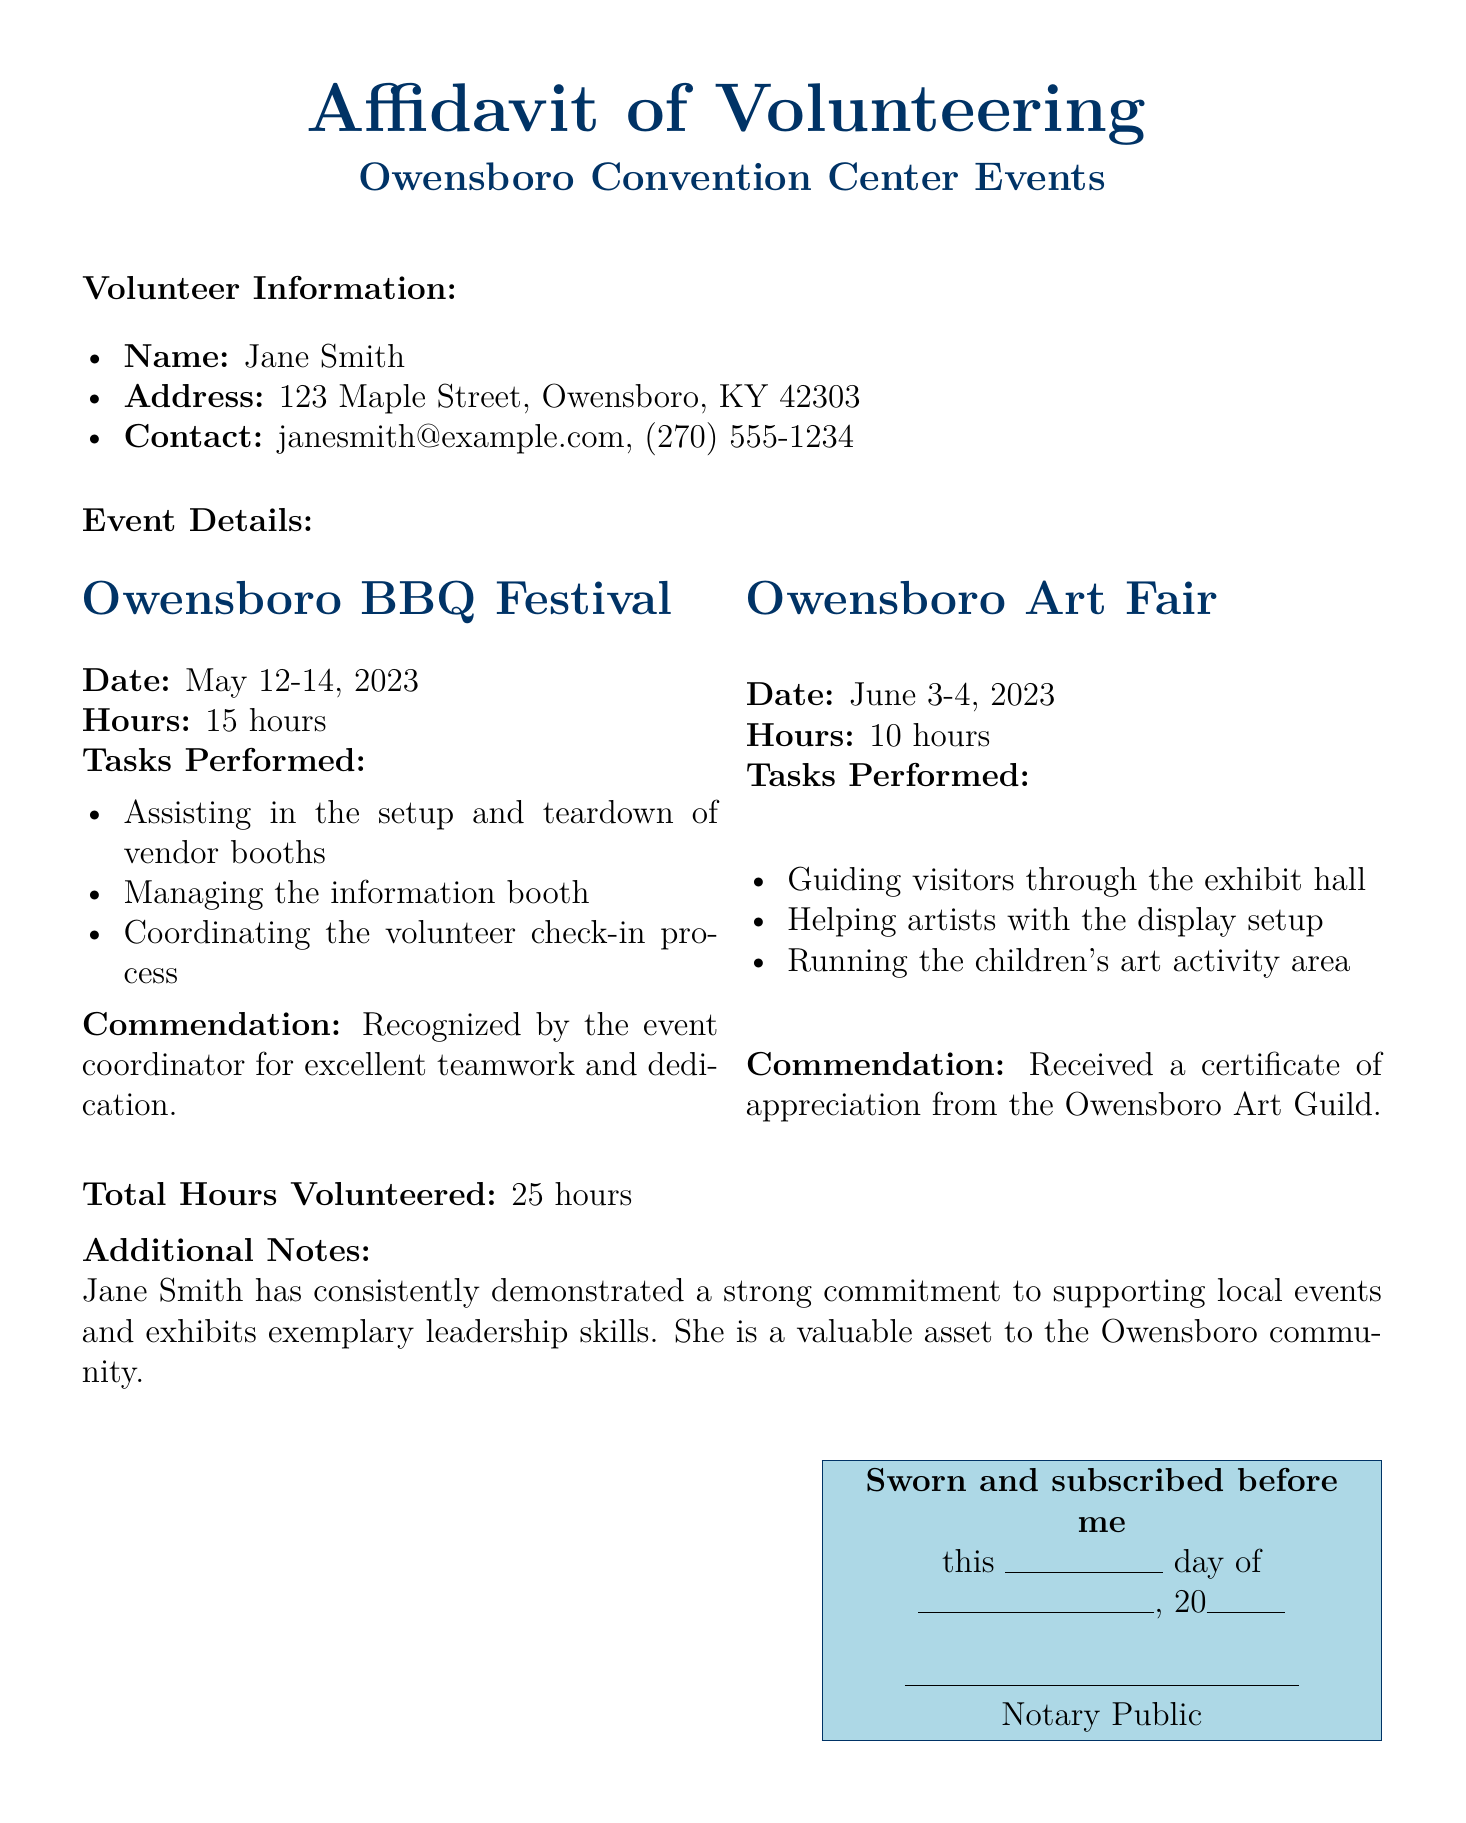What is the name of the volunteer? The document states the volunteer's name as Jane Smith.
Answer: Jane Smith What is the address of the volunteer? The address listed in the document is 123 Maple Street, Owensboro, KY 42303.
Answer: 123 Maple Street, Owensboro, KY 42303 How many total hours were volunteered? The total hours volunteered is summarized at the end of the document. It states a total of 25 hours.
Answer: 25 hours What task did Jane Smith perform at the BBQ Festival? The document lists several tasks, with one being assisting in the setup and teardown of vendor booths.
Answer: Assisting in the setup and teardown of vendor booths What commendation did Jane Smith receive at the Art Fair? The document indicates that she received a certificate of appreciation from the Owensboro Art Guild.
Answer: Certificate of appreciation from the Owensboro Art Guild What were the dates of the Owensboro BBQ Festival? The document specifies that the event took place from May 12-14, 2023.
Answer: May 12-14, 2023 What was Jane Smith recognized for at the BBQ Festival? The document mentions that she was recognized for excellent teamwork and dedication by the event coordinator.
Answer: Excellent teamwork and dedication How many hours did Jane volunteer for the Art Fair? The hours volunteered at the Art Fair are explicitly mentioned in the document as 10 hours.
Answer: 10 hours Who is the notary public for this affidavit? The document does not provide a specific name for the notary public, stating only "Notary Public."
Answer: Notary Public 